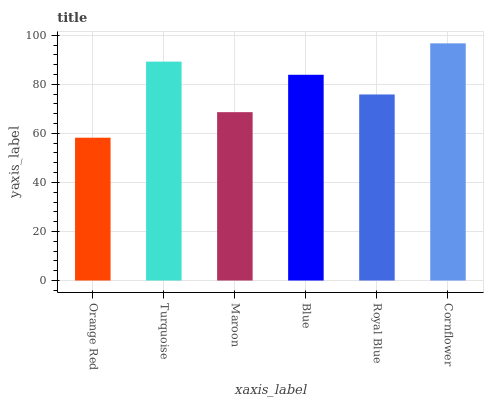Is Orange Red the minimum?
Answer yes or no. Yes. Is Cornflower the maximum?
Answer yes or no. Yes. Is Turquoise the minimum?
Answer yes or no. No. Is Turquoise the maximum?
Answer yes or no. No. Is Turquoise greater than Orange Red?
Answer yes or no. Yes. Is Orange Red less than Turquoise?
Answer yes or no. Yes. Is Orange Red greater than Turquoise?
Answer yes or no. No. Is Turquoise less than Orange Red?
Answer yes or no. No. Is Blue the high median?
Answer yes or no. Yes. Is Royal Blue the low median?
Answer yes or no. Yes. Is Orange Red the high median?
Answer yes or no. No. Is Turquoise the low median?
Answer yes or no. No. 